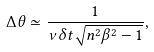Convert formula to latex. <formula><loc_0><loc_0><loc_500><loc_500>\Delta \theta \simeq \frac { 1 } { \nu \delta t \sqrt { n ^ { 2 } \beta ^ { 2 } - 1 } } ,</formula> 